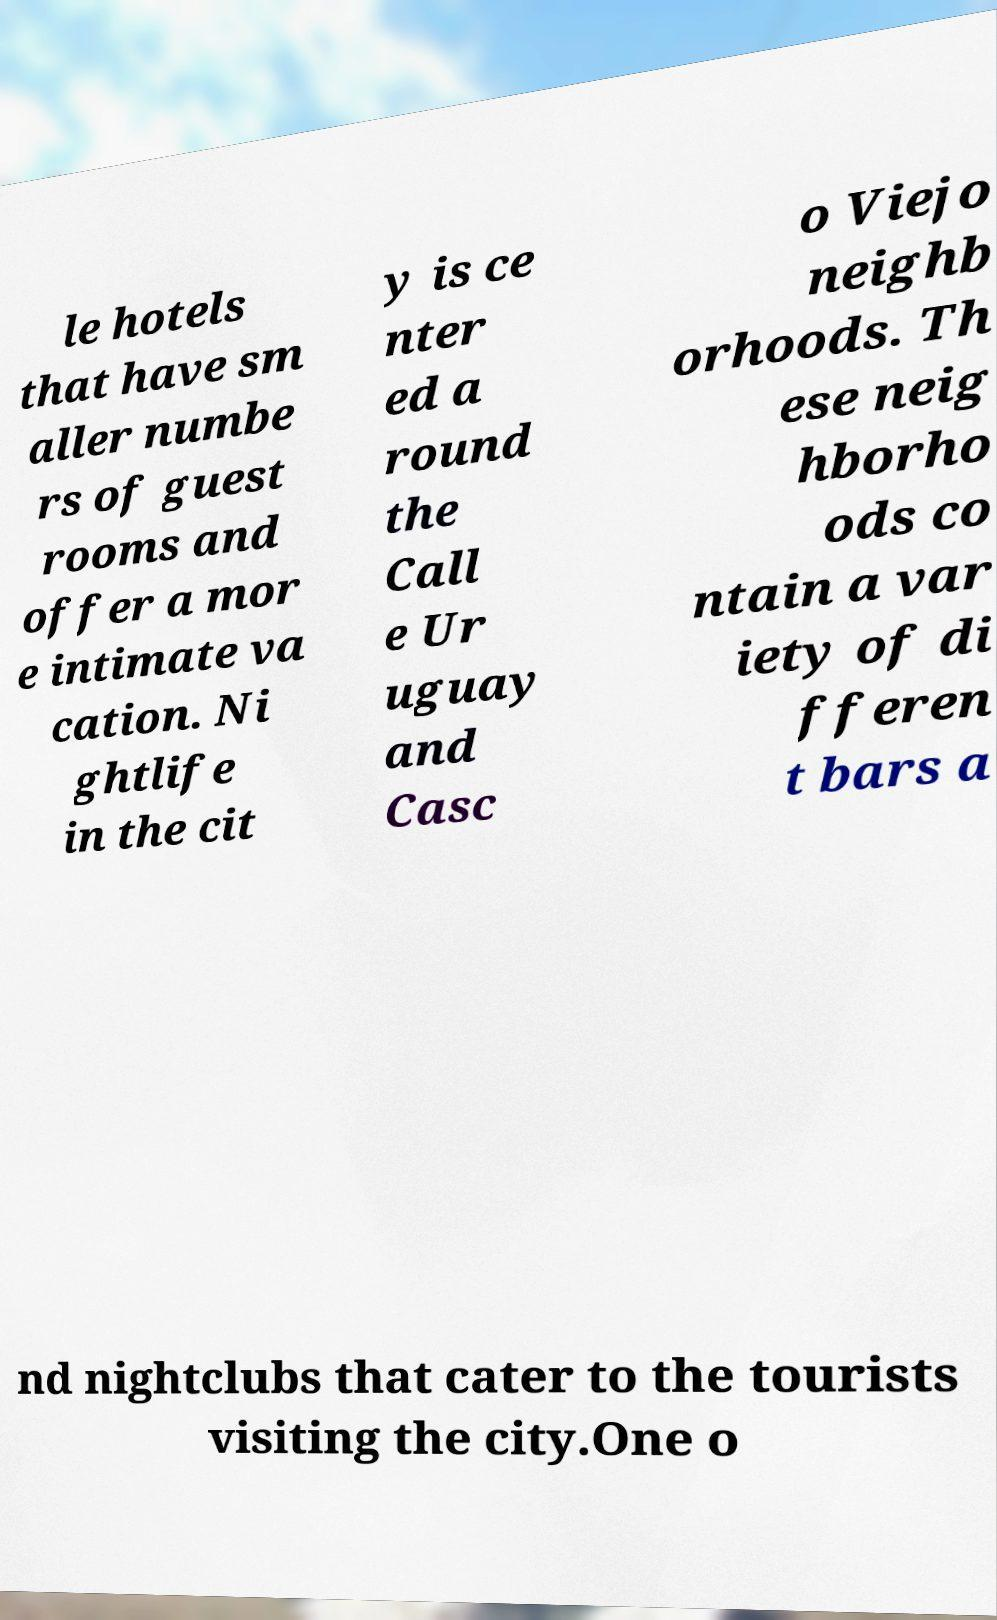What messages or text are displayed in this image? I need them in a readable, typed format. le hotels that have sm aller numbe rs of guest rooms and offer a mor e intimate va cation. Ni ghtlife in the cit y is ce nter ed a round the Call e Ur uguay and Casc o Viejo neighb orhoods. Th ese neig hborho ods co ntain a var iety of di fferen t bars a nd nightclubs that cater to the tourists visiting the city.One o 